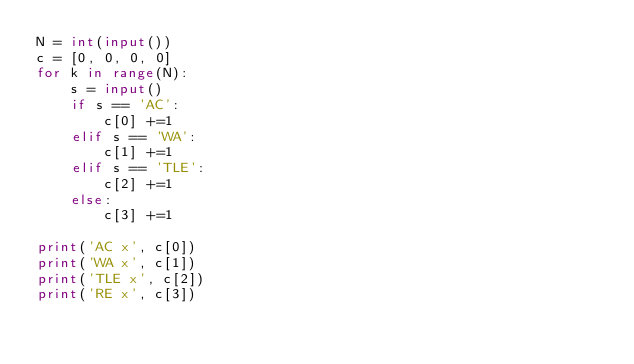<code> <loc_0><loc_0><loc_500><loc_500><_Python_>N = int(input())
c = [0, 0, 0, 0]
for k in range(N):
    s = input()
    if s == 'AC':
        c[0] +=1
    elif s == 'WA':
        c[1] +=1
    elif s == 'TLE':
        c[2] +=1
    else:
        c[3] +=1

print('AC x', c[0])
print('WA x', c[1])
print('TLE x', c[2])
print('RE x', c[3])</code> 